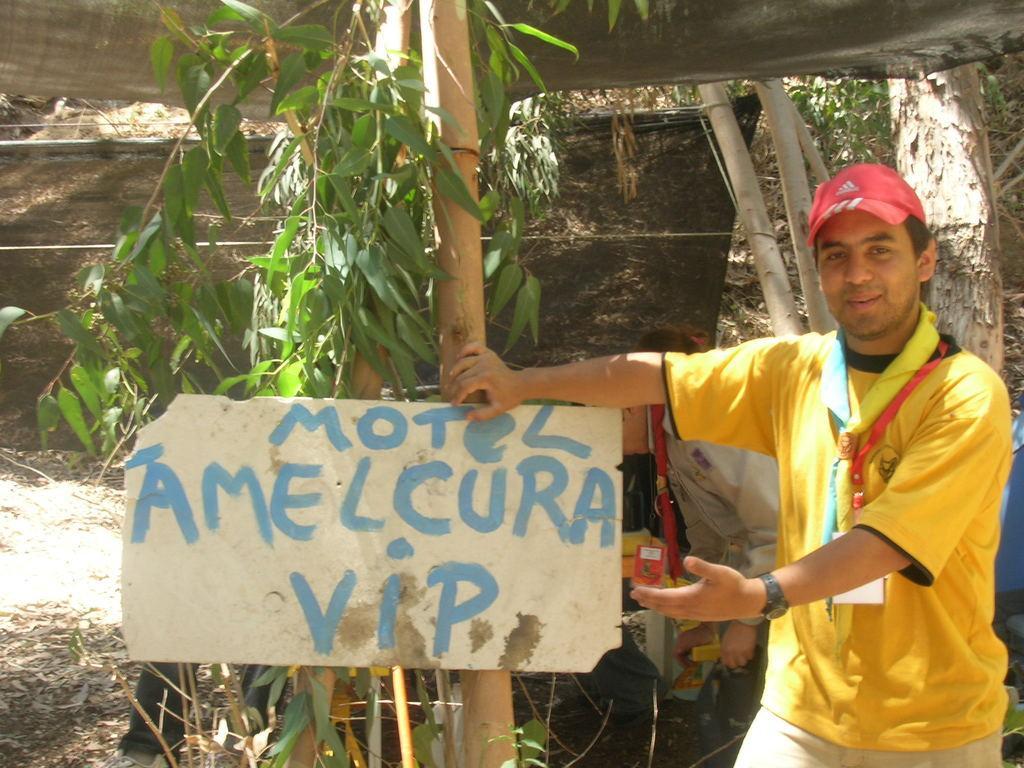Could you give a brief overview of what you see in this image? In this picture there is a man standing and we can see board on tree, behind him we can see people, trees and tent. 